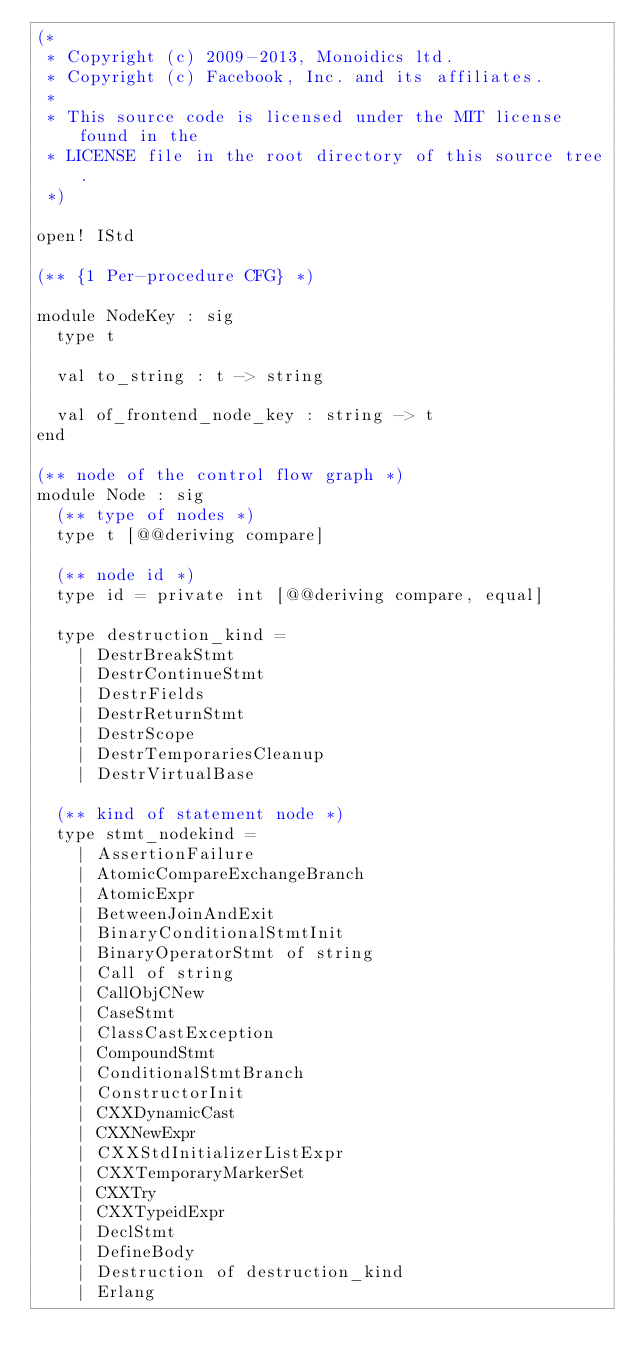Convert code to text. <code><loc_0><loc_0><loc_500><loc_500><_OCaml_>(*
 * Copyright (c) 2009-2013, Monoidics ltd.
 * Copyright (c) Facebook, Inc. and its affiliates.
 *
 * This source code is licensed under the MIT license found in the
 * LICENSE file in the root directory of this source tree.
 *)

open! IStd

(** {1 Per-procedure CFG} *)

module NodeKey : sig
  type t

  val to_string : t -> string

  val of_frontend_node_key : string -> t
end

(** node of the control flow graph *)
module Node : sig
  (** type of nodes *)
  type t [@@deriving compare]

  (** node id *)
  type id = private int [@@deriving compare, equal]

  type destruction_kind =
    | DestrBreakStmt
    | DestrContinueStmt
    | DestrFields
    | DestrReturnStmt
    | DestrScope
    | DestrTemporariesCleanup
    | DestrVirtualBase

  (** kind of statement node *)
  type stmt_nodekind =
    | AssertionFailure
    | AtomicCompareExchangeBranch
    | AtomicExpr
    | BetweenJoinAndExit
    | BinaryConditionalStmtInit
    | BinaryOperatorStmt of string
    | Call of string
    | CallObjCNew
    | CaseStmt
    | ClassCastException
    | CompoundStmt
    | ConditionalStmtBranch
    | ConstructorInit
    | CXXDynamicCast
    | CXXNewExpr
    | CXXStdInitializerListExpr
    | CXXTemporaryMarkerSet
    | CXXTry
    | CXXTypeidExpr
    | DeclStmt
    | DefineBody
    | Destruction of destruction_kind
    | Erlang</code> 